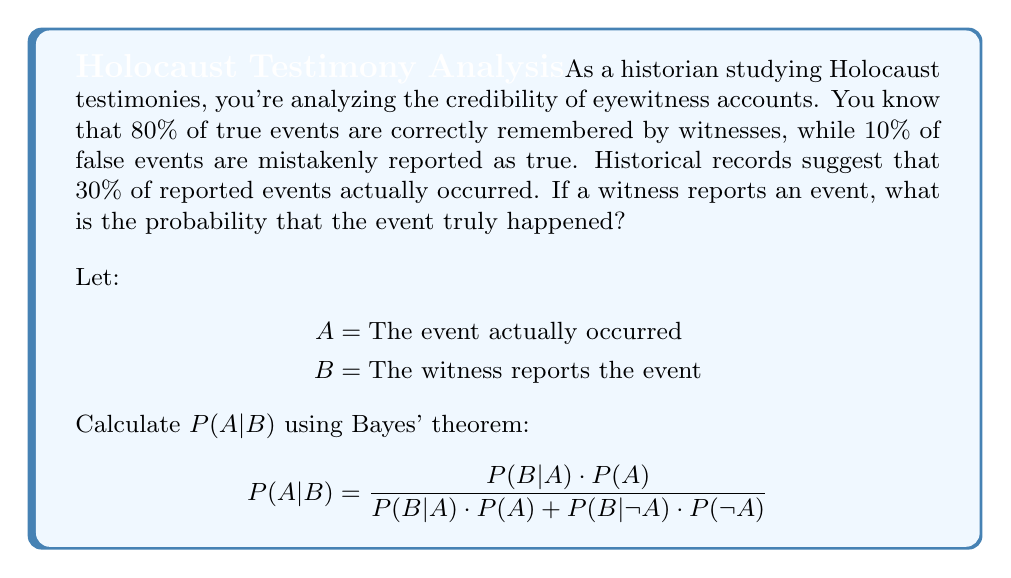What is the answer to this math problem? To solve this problem using Bayes' theorem, we need to identify the given probabilities:

1. $P(B|A) = 0.80$ (80% of true events are correctly remembered)
2. $P(B|\neg A) = 0.10$ (10% of false events are mistakenly reported as true)
3. $P(A) = 0.30$ (30% of reported events actually occurred)
4. $P(\neg A) = 1 - P(A) = 0.70$ (70% of reported events did not occur)

Now, let's apply Bayes' theorem:

$$P(A|B) = \frac{P(B|A) \cdot P(A)}{P(B|A) \cdot P(A) + P(B|\neg A) \cdot P(\neg A)}$$

Substituting the values:

$$P(A|B) = \frac{0.80 \cdot 0.30}{0.80 \cdot 0.30 + 0.10 \cdot 0.70}$$

$$P(A|B) = \frac{0.24}{0.24 + 0.07}$$

$$P(A|B) = \frac{0.24}{0.31}$$

$$P(A|B) \approx 0.7742$$

Converting to a percentage:

$$P(A|B) \approx 77.42\%$$

Therefore, if a witness reports an event, there is approximately a 77.42% probability that the event truly happened.
Answer: 77.42% 